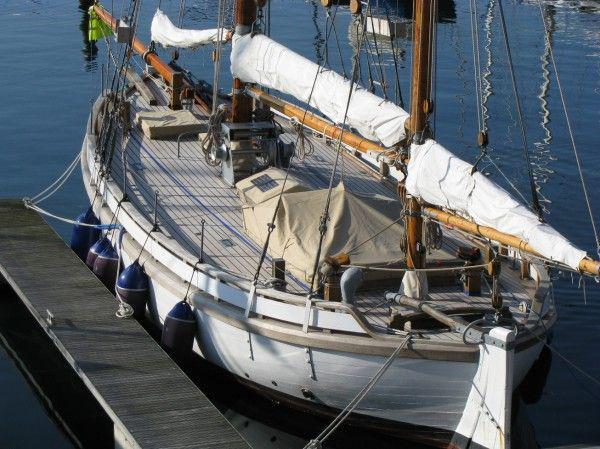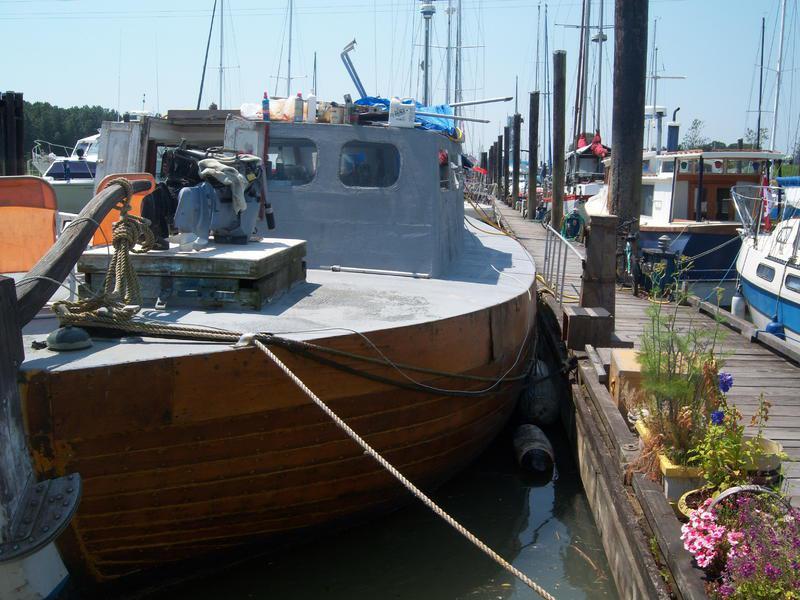The first image is the image on the left, the second image is the image on the right. Analyze the images presented: Is the assertion "In one image there is a boat that is in harbor with the dock on the right side of the image." valid? Answer yes or no. Yes. The first image is the image on the left, the second image is the image on the right. For the images displayed, is the sentence "Some of the boats have multiple flags attached to them and none are American Flags." factually correct? Answer yes or no. No. The first image is the image on the left, the second image is the image on the right. For the images displayed, is the sentence "Atleast one of the pictures doesn't have a white boat." factually correct? Answer yes or no. Yes. 